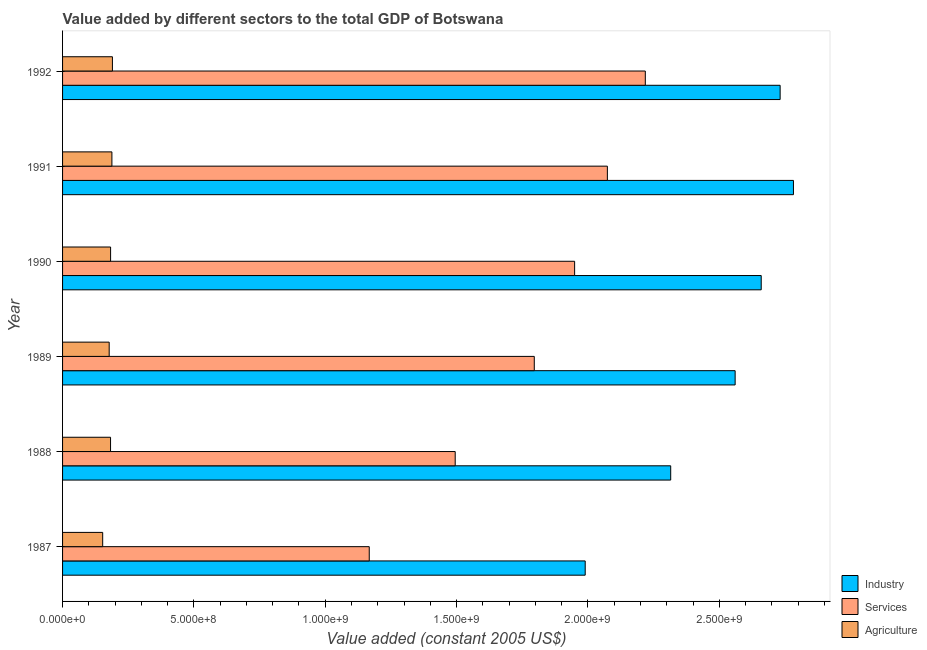How many different coloured bars are there?
Offer a terse response. 3. How many groups of bars are there?
Your answer should be very brief. 6. Are the number of bars on each tick of the Y-axis equal?
Keep it short and to the point. Yes. How many bars are there on the 6th tick from the top?
Make the answer very short. 3. How many bars are there on the 3rd tick from the bottom?
Ensure brevity in your answer.  3. What is the label of the 6th group of bars from the top?
Ensure brevity in your answer.  1987. What is the value added by agricultural sector in 1991?
Offer a terse response. 1.88e+08. Across all years, what is the maximum value added by services?
Your answer should be compact. 2.22e+09. Across all years, what is the minimum value added by industrial sector?
Offer a very short reply. 1.99e+09. In which year was the value added by agricultural sector minimum?
Your answer should be compact. 1987. What is the total value added by agricultural sector in the graph?
Your answer should be compact. 1.07e+09. What is the difference between the value added by industrial sector in 1988 and that in 1990?
Provide a succinct answer. -3.45e+08. What is the difference between the value added by industrial sector in 1992 and the value added by services in 1989?
Provide a short and direct response. 9.36e+08. What is the average value added by services per year?
Provide a short and direct response. 1.78e+09. In the year 1988, what is the difference between the value added by services and value added by agricultural sector?
Provide a succinct answer. 1.31e+09. In how many years, is the value added by agricultural sector greater than 1600000000 US$?
Your response must be concise. 0. What is the ratio of the value added by industrial sector in 1989 to that in 1992?
Keep it short and to the point. 0.94. Is the value added by services in 1988 less than that in 1990?
Make the answer very short. Yes. What is the difference between the highest and the second highest value added by industrial sector?
Provide a short and direct response. 5.07e+07. What is the difference between the highest and the lowest value added by services?
Give a very brief answer. 1.05e+09. In how many years, is the value added by industrial sector greater than the average value added by industrial sector taken over all years?
Give a very brief answer. 4. What does the 3rd bar from the top in 1987 represents?
Your answer should be very brief. Industry. What does the 1st bar from the bottom in 1987 represents?
Make the answer very short. Industry. How many bars are there?
Make the answer very short. 18. Are all the bars in the graph horizontal?
Your answer should be very brief. Yes. How many years are there in the graph?
Ensure brevity in your answer.  6. Are the values on the major ticks of X-axis written in scientific E-notation?
Your answer should be compact. Yes. Does the graph contain any zero values?
Ensure brevity in your answer.  No. Where does the legend appear in the graph?
Make the answer very short. Bottom right. How are the legend labels stacked?
Make the answer very short. Vertical. What is the title of the graph?
Your response must be concise. Value added by different sectors to the total GDP of Botswana. Does "Resident buildings and public services" appear as one of the legend labels in the graph?
Your answer should be compact. No. What is the label or title of the X-axis?
Offer a terse response. Value added (constant 2005 US$). What is the label or title of the Y-axis?
Provide a short and direct response. Year. What is the Value added (constant 2005 US$) in Industry in 1987?
Give a very brief answer. 1.99e+09. What is the Value added (constant 2005 US$) in Services in 1987?
Give a very brief answer. 1.17e+09. What is the Value added (constant 2005 US$) in Agriculture in 1987?
Your answer should be compact. 1.53e+08. What is the Value added (constant 2005 US$) in Industry in 1988?
Provide a short and direct response. 2.32e+09. What is the Value added (constant 2005 US$) in Services in 1988?
Your response must be concise. 1.49e+09. What is the Value added (constant 2005 US$) in Agriculture in 1988?
Offer a terse response. 1.83e+08. What is the Value added (constant 2005 US$) in Industry in 1989?
Offer a very short reply. 2.56e+09. What is the Value added (constant 2005 US$) in Services in 1989?
Your answer should be very brief. 1.80e+09. What is the Value added (constant 2005 US$) of Agriculture in 1989?
Provide a succinct answer. 1.77e+08. What is the Value added (constant 2005 US$) in Industry in 1990?
Your answer should be compact. 2.66e+09. What is the Value added (constant 2005 US$) in Services in 1990?
Make the answer very short. 1.95e+09. What is the Value added (constant 2005 US$) of Agriculture in 1990?
Offer a very short reply. 1.83e+08. What is the Value added (constant 2005 US$) of Industry in 1991?
Your answer should be compact. 2.78e+09. What is the Value added (constant 2005 US$) in Services in 1991?
Offer a terse response. 2.07e+09. What is the Value added (constant 2005 US$) in Agriculture in 1991?
Make the answer very short. 1.88e+08. What is the Value added (constant 2005 US$) in Industry in 1992?
Keep it short and to the point. 2.73e+09. What is the Value added (constant 2005 US$) of Services in 1992?
Offer a very short reply. 2.22e+09. What is the Value added (constant 2005 US$) of Agriculture in 1992?
Give a very brief answer. 1.90e+08. Across all years, what is the maximum Value added (constant 2005 US$) in Industry?
Your answer should be compact. 2.78e+09. Across all years, what is the maximum Value added (constant 2005 US$) of Services?
Give a very brief answer. 2.22e+09. Across all years, what is the maximum Value added (constant 2005 US$) of Agriculture?
Make the answer very short. 1.90e+08. Across all years, what is the minimum Value added (constant 2005 US$) in Industry?
Offer a terse response. 1.99e+09. Across all years, what is the minimum Value added (constant 2005 US$) in Services?
Make the answer very short. 1.17e+09. Across all years, what is the minimum Value added (constant 2005 US$) in Agriculture?
Make the answer very short. 1.53e+08. What is the total Value added (constant 2005 US$) of Industry in the graph?
Give a very brief answer. 1.50e+1. What is the total Value added (constant 2005 US$) of Services in the graph?
Your response must be concise. 1.07e+1. What is the total Value added (constant 2005 US$) of Agriculture in the graph?
Your answer should be very brief. 1.07e+09. What is the difference between the Value added (constant 2005 US$) in Industry in 1987 and that in 1988?
Give a very brief answer. -3.25e+08. What is the difference between the Value added (constant 2005 US$) in Services in 1987 and that in 1988?
Give a very brief answer. -3.27e+08. What is the difference between the Value added (constant 2005 US$) in Agriculture in 1987 and that in 1988?
Ensure brevity in your answer.  -2.99e+07. What is the difference between the Value added (constant 2005 US$) of Industry in 1987 and that in 1989?
Provide a succinct answer. -5.71e+08. What is the difference between the Value added (constant 2005 US$) in Services in 1987 and that in 1989?
Offer a terse response. -6.28e+08. What is the difference between the Value added (constant 2005 US$) in Agriculture in 1987 and that in 1989?
Your answer should be very brief. -2.48e+07. What is the difference between the Value added (constant 2005 US$) of Industry in 1987 and that in 1990?
Provide a succinct answer. -6.70e+08. What is the difference between the Value added (constant 2005 US$) in Services in 1987 and that in 1990?
Ensure brevity in your answer.  -7.82e+08. What is the difference between the Value added (constant 2005 US$) of Agriculture in 1987 and that in 1990?
Provide a succinct answer. -3.01e+07. What is the difference between the Value added (constant 2005 US$) of Industry in 1987 and that in 1991?
Provide a succinct answer. -7.93e+08. What is the difference between the Value added (constant 2005 US$) in Services in 1987 and that in 1991?
Provide a short and direct response. -9.07e+08. What is the difference between the Value added (constant 2005 US$) in Agriculture in 1987 and that in 1991?
Your response must be concise. -3.51e+07. What is the difference between the Value added (constant 2005 US$) of Industry in 1987 and that in 1992?
Offer a very short reply. -7.42e+08. What is the difference between the Value added (constant 2005 US$) of Services in 1987 and that in 1992?
Your response must be concise. -1.05e+09. What is the difference between the Value added (constant 2005 US$) of Agriculture in 1987 and that in 1992?
Ensure brevity in your answer.  -3.71e+07. What is the difference between the Value added (constant 2005 US$) in Industry in 1988 and that in 1989?
Provide a short and direct response. -2.45e+08. What is the difference between the Value added (constant 2005 US$) in Services in 1988 and that in 1989?
Your answer should be compact. -3.01e+08. What is the difference between the Value added (constant 2005 US$) in Agriculture in 1988 and that in 1989?
Give a very brief answer. 5.15e+06. What is the difference between the Value added (constant 2005 US$) of Industry in 1988 and that in 1990?
Provide a short and direct response. -3.45e+08. What is the difference between the Value added (constant 2005 US$) in Services in 1988 and that in 1990?
Your answer should be compact. -4.55e+08. What is the difference between the Value added (constant 2005 US$) in Agriculture in 1988 and that in 1990?
Your answer should be very brief. -1.94e+05. What is the difference between the Value added (constant 2005 US$) in Industry in 1988 and that in 1991?
Make the answer very short. -4.67e+08. What is the difference between the Value added (constant 2005 US$) of Services in 1988 and that in 1991?
Provide a short and direct response. -5.79e+08. What is the difference between the Value added (constant 2005 US$) in Agriculture in 1988 and that in 1991?
Offer a terse response. -5.19e+06. What is the difference between the Value added (constant 2005 US$) of Industry in 1988 and that in 1992?
Your answer should be very brief. -4.17e+08. What is the difference between the Value added (constant 2005 US$) of Services in 1988 and that in 1992?
Offer a terse response. -7.24e+08. What is the difference between the Value added (constant 2005 US$) of Agriculture in 1988 and that in 1992?
Keep it short and to the point. -7.17e+06. What is the difference between the Value added (constant 2005 US$) of Industry in 1989 and that in 1990?
Ensure brevity in your answer.  -9.93e+07. What is the difference between the Value added (constant 2005 US$) of Services in 1989 and that in 1990?
Offer a very short reply. -1.54e+08. What is the difference between the Value added (constant 2005 US$) in Agriculture in 1989 and that in 1990?
Keep it short and to the point. -5.35e+06. What is the difference between the Value added (constant 2005 US$) in Industry in 1989 and that in 1991?
Keep it short and to the point. -2.22e+08. What is the difference between the Value added (constant 2005 US$) of Services in 1989 and that in 1991?
Keep it short and to the point. -2.78e+08. What is the difference between the Value added (constant 2005 US$) in Agriculture in 1989 and that in 1991?
Make the answer very short. -1.03e+07. What is the difference between the Value added (constant 2005 US$) in Industry in 1989 and that in 1992?
Ensure brevity in your answer.  -1.71e+08. What is the difference between the Value added (constant 2005 US$) in Services in 1989 and that in 1992?
Offer a terse response. -4.23e+08. What is the difference between the Value added (constant 2005 US$) of Agriculture in 1989 and that in 1992?
Provide a short and direct response. -1.23e+07. What is the difference between the Value added (constant 2005 US$) in Industry in 1990 and that in 1991?
Keep it short and to the point. -1.23e+08. What is the difference between the Value added (constant 2005 US$) in Services in 1990 and that in 1991?
Provide a short and direct response. -1.25e+08. What is the difference between the Value added (constant 2005 US$) in Agriculture in 1990 and that in 1991?
Ensure brevity in your answer.  -5.00e+06. What is the difference between the Value added (constant 2005 US$) of Industry in 1990 and that in 1992?
Offer a very short reply. -7.20e+07. What is the difference between the Value added (constant 2005 US$) of Services in 1990 and that in 1992?
Give a very brief answer. -2.69e+08. What is the difference between the Value added (constant 2005 US$) of Agriculture in 1990 and that in 1992?
Your answer should be compact. -6.97e+06. What is the difference between the Value added (constant 2005 US$) in Industry in 1991 and that in 1992?
Give a very brief answer. 5.07e+07. What is the difference between the Value added (constant 2005 US$) in Services in 1991 and that in 1992?
Provide a succinct answer. -1.44e+08. What is the difference between the Value added (constant 2005 US$) of Agriculture in 1991 and that in 1992?
Give a very brief answer. -1.98e+06. What is the difference between the Value added (constant 2005 US$) of Industry in 1987 and the Value added (constant 2005 US$) of Services in 1988?
Your answer should be compact. 4.95e+08. What is the difference between the Value added (constant 2005 US$) of Industry in 1987 and the Value added (constant 2005 US$) of Agriculture in 1988?
Offer a very short reply. 1.81e+09. What is the difference between the Value added (constant 2005 US$) in Services in 1987 and the Value added (constant 2005 US$) in Agriculture in 1988?
Your answer should be very brief. 9.85e+08. What is the difference between the Value added (constant 2005 US$) of Industry in 1987 and the Value added (constant 2005 US$) of Services in 1989?
Give a very brief answer. 1.94e+08. What is the difference between the Value added (constant 2005 US$) in Industry in 1987 and the Value added (constant 2005 US$) in Agriculture in 1989?
Provide a succinct answer. 1.81e+09. What is the difference between the Value added (constant 2005 US$) of Services in 1987 and the Value added (constant 2005 US$) of Agriculture in 1989?
Provide a succinct answer. 9.90e+08. What is the difference between the Value added (constant 2005 US$) of Industry in 1987 and the Value added (constant 2005 US$) of Services in 1990?
Your answer should be compact. 4.03e+07. What is the difference between the Value added (constant 2005 US$) of Industry in 1987 and the Value added (constant 2005 US$) of Agriculture in 1990?
Your response must be concise. 1.81e+09. What is the difference between the Value added (constant 2005 US$) in Services in 1987 and the Value added (constant 2005 US$) in Agriculture in 1990?
Your response must be concise. 9.85e+08. What is the difference between the Value added (constant 2005 US$) of Industry in 1987 and the Value added (constant 2005 US$) of Services in 1991?
Make the answer very short. -8.44e+07. What is the difference between the Value added (constant 2005 US$) of Industry in 1987 and the Value added (constant 2005 US$) of Agriculture in 1991?
Offer a terse response. 1.80e+09. What is the difference between the Value added (constant 2005 US$) of Services in 1987 and the Value added (constant 2005 US$) of Agriculture in 1991?
Ensure brevity in your answer.  9.80e+08. What is the difference between the Value added (constant 2005 US$) of Industry in 1987 and the Value added (constant 2005 US$) of Services in 1992?
Your response must be concise. -2.29e+08. What is the difference between the Value added (constant 2005 US$) of Industry in 1987 and the Value added (constant 2005 US$) of Agriculture in 1992?
Offer a terse response. 1.80e+09. What is the difference between the Value added (constant 2005 US$) in Services in 1987 and the Value added (constant 2005 US$) in Agriculture in 1992?
Offer a very short reply. 9.78e+08. What is the difference between the Value added (constant 2005 US$) of Industry in 1988 and the Value added (constant 2005 US$) of Services in 1989?
Make the answer very short. 5.19e+08. What is the difference between the Value added (constant 2005 US$) in Industry in 1988 and the Value added (constant 2005 US$) in Agriculture in 1989?
Ensure brevity in your answer.  2.14e+09. What is the difference between the Value added (constant 2005 US$) in Services in 1988 and the Value added (constant 2005 US$) in Agriculture in 1989?
Keep it short and to the point. 1.32e+09. What is the difference between the Value added (constant 2005 US$) in Industry in 1988 and the Value added (constant 2005 US$) in Services in 1990?
Provide a succinct answer. 3.66e+08. What is the difference between the Value added (constant 2005 US$) of Industry in 1988 and the Value added (constant 2005 US$) of Agriculture in 1990?
Make the answer very short. 2.13e+09. What is the difference between the Value added (constant 2005 US$) in Services in 1988 and the Value added (constant 2005 US$) in Agriculture in 1990?
Keep it short and to the point. 1.31e+09. What is the difference between the Value added (constant 2005 US$) in Industry in 1988 and the Value added (constant 2005 US$) in Services in 1991?
Ensure brevity in your answer.  2.41e+08. What is the difference between the Value added (constant 2005 US$) of Industry in 1988 and the Value added (constant 2005 US$) of Agriculture in 1991?
Your answer should be compact. 2.13e+09. What is the difference between the Value added (constant 2005 US$) of Services in 1988 and the Value added (constant 2005 US$) of Agriculture in 1991?
Offer a terse response. 1.31e+09. What is the difference between the Value added (constant 2005 US$) in Industry in 1988 and the Value added (constant 2005 US$) in Services in 1992?
Ensure brevity in your answer.  9.66e+07. What is the difference between the Value added (constant 2005 US$) of Industry in 1988 and the Value added (constant 2005 US$) of Agriculture in 1992?
Provide a succinct answer. 2.13e+09. What is the difference between the Value added (constant 2005 US$) in Services in 1988 and the Value added (constant 2005 US$) in Agriculture in 1992?
Your response must be concise. 1.30e+09. What is the difference between the Value added (constant 2005 US$) in Industry in 1989 and the Value added (constant 2005 US$) in Services in 1990?
Make the answer very short. 6.11e+08. What is the difference between the Value added (constant 2005 US$) in Industry in 1989 and the Value added (constant 2005 US$) in Agriculture in 1990?
Offer a very short reply. 2.38e+09. What is the difference between the Value added (constant 2005 US$) in Services in 1989 and the Value added (constant 2005 US$) in Agriculture in 1990?
Keep it short and to the point. 1.61e+09. What is the difference between the Value added (constant 2005 US$) of Industry in 1989 and the Value added (constant 2005 US$) of Services in 1991?
Your answer should be compact. 4.86e+08. What is the difference between the Value added (constant 2005 US$) in Industry in 1989 and the Value added (constant 2005 US$) in Agriculture in 1991?
Provide a short and direct response. 2.37e+09. What is the difference between the Value added (constant 2005 US$) in Services in 1989 and the Value added (constant 2005 US$) in Agriculture in 1991?
Provide a short and direct response. 1.61e+09. What is the difference between the Value added (constant 2005 US$) of Industry in 1989 and the Value added (constant 2005 US$) of Services in 1992?
Offer a terse response. 3.42e+08. What is the difference between the Value added (constant 2005 US$) of Industry in 1989 and the Value added (constant 2005 US$) of Agriculture in 1992?
Provide a succinct answer. 2.37e+09. What is the difference between the Value added (constant 2005 US$) in Services in 1989 and the Value added (constant 2005 US$) in Agriculture in 1992?
Your answer should be very brief. 1.61e+09. What is the difference between the Value added (constant 2005 US$) in Industry in 1990 and the Value added (constant 2005 US$) in Services in 1991?
Make the answer very short. 5.86e+08. What is the difference between the Value added (constant 2005 US$) in Industry in 1990 and the Value added (constant 2005 US$) in Agriculture in 1991?
Keep it short and to the point. 2.47e+09. What is the difference between the Value added (constant 2005 US$) in Services in 1990 and the Value added (constant 2005 US$) in Agriculture in 1991?
Your answer should be very brief. 1.76e+09. What is the difference between the Value added (constant 2005 US$) in Industry in 1990 and the Value added (constant 2005 US$) in Services in 1992?
Your answer should be very brief. 4.41e+08. What is the difference between the Value added (constant 2005 US$) of Industry in 1990 and the Value added (constant 2005 US$) of Agriculture in 1992?
Offer a terse response. 2.47e+09. What is the difference between the Value added (constant 2005 US$) in Services in 1990 and the Value added (constant 2005 US$) in Agriculture in 1992?
Your answer should be compact. 1.76e+09. What is the difference between the Value added (constant 2005 US$) of Industry in 1991 and the Value added (constant 2005 US$) of Services in 1992?
Provide a short and direct response. 5.64e+08. What is the difference between the Value added (constant 2005 US$) in Industry in 1991 and the Value added (constant 2005 US$) in Agriculture in 1992?
Keep it short and to the point. 2.59e+09. What is the difference between the Value added (constant 2005 US$) in Services in 1991 and the Value added (constant 2005 US$) in Agriculture in 1992?
Your answer should be very brief. 1.88e+09. What is the average Value added (constant 2005 US$) in Industry per year?
Your answer should be compact. 2.51e+09. What is the average Value added (constant 2005 US$) in Services per year?
Offer a terse response. 1.78e+09. What is the average Value added (constant 2005 US$) in Agriculture per year?
Make the answer very short. 1.79e+08. In the year 1987, what is the difference between the Value added (constant 2005 US$) in Industry and Value added (constant 2005 US$) in Services?
Offer a very short reply. 8.22e+08. In the year 1987, what is the difference between the Value added (constant 2005 US$) of Industry and Value added (constant 2005 US$) of Agriculture?
Provide a short and direct response. 1.84e+09. In the year 1987, what is the difference between the Value added (constant 2005 US$) in Services and Value added (constant 2005 US$) in Agriculture?
Give a very brief answer. 1.01e+09. In the year 1988, what is the difference between the Value added (constant 2005 US$) in Industry and Value added (constant 2005 US$) in Services?
Your answer should be compact. 8.20e+08. In the year 1988, what is the difference between the Value added (constant 2005 US$) of Industry and Value added (constant 2005 US$) of Agriculture?
Keep it short and to the point. 2.13e+09. In the year 1988, what is the difference between the Value added (constant 2005 US$) in Services and Value added (constant 2005 US$) in Agriculture?
Give a very brief answer. 1.31e+09. In the year 1989, what is the difference between the Value added (constant 2005 US$) in Industry and Value added (constant 2005 US$) in Services?
Your answer should be very brief. 7.65e+08. In the year 1989, what is the difference between the Value added (constant 2005 US$) in Industry and Value added (constant 2005 US$) in Agriculture?
Your answer should be very brief. 2.38e+09. In the year 1989, what is the difference between the Value added (constant 2005 US$) in Services and Value added (constant 2005 US$) in Agriculture?
Make the answer very short. 1.62e+09. In the year 1990, what is the difference between the Value added (constant 2005 US$) in Industry and Value added (constant 2005 US$) in Services?
Offer a very short reply. 7.10e+08. In the year 1990, what is the difference between the Value added (constant 2005 US$) in Industry and Value added (constant 2005 US$) in Agriculture?
Offer a very short reply. 2.48e+09. In the year 1990, what is the difference between the Value added (constant 2005 US$) of Services and Value added (constant 2005 US$) of Agriculture?
Provide a succinct answer. 1.77e+09. In the year 1991, what is the difference between the Value added (constant 2005 US$) of Industry and Value added (constant 2005 US$) of Services?
Offer a very short reply. 7.08e+08. In the year 1991, what is the difference between the Value added (constant 2005 US$) of Industry and Value added (constant 2005 US$) of Agriculture?
Keep it short and to the point. 2.59e+09. In the year 1991, what is the difference between the Value added (constant 2005 US$) of Services and Value added (constant 2005 US$) of Agriculture?
Make the answer very short. 1.89e+09. In the year 1992, what is the difference between the Value added (constant 2005 US$) of Industry and Value added (constant 2005 US$) of Services?
Provide a short and direct response. 5.13e+08. In the year 1992, what is the difference between the Value added (constant 2005 US$) in Industry and Value added (constant 2005 US$) in Agriculture?
Your answer should be compact. 2.54e+09. In the year 1992, what is the difference between the Value added (constant 2005 US$) in Services and Value added (constant 2005 US$) in Agriculture?
Offer a terse response. 2.03e+09. What is the ratio of the Value added (constant 2005 US$) in Industry in 1987 to that in 1988?
Provide a succinct answer. 0.86. What is the ratio of the Value added (constant 2005 US$) of Services in 1987 to that in 1988?
Provide a succinct answer. 0.78. What is the ratio of the Value added (constant 2005 US$) of Agriculture in 1987 to that in 1988?
Give a very brief answer. 0.84. What is the ratio of the Value added (constant 2005 US$) of Industry in 1987 to that in 1989?
Make the answer very short. 0.78. What is the ratio of the Value added (constant 2005 US$) in Services in 1987 to that in 1989?
Your answer should be very brief. 0.65. What is the ratio of the Value added (constant 2005 US$) in Agriculture in 1987 to that in 1989?
Provide a succinct answer. 0.86. What is the ratio of the Value added (constant 2005 US$) of Industry in 1987 to that in 1990?
Keep it short and to the point. 0.75. What is the ratio of the Value added (constant 2005 US$) of Services in 1987 to that in 1990?
Offer a very short reply. 0.6. What is the ratio of the Value added (constant 2005 US$) of Agriculture in 1987 to that in 1990?
Ensure brevity in your answer.  0.84. What is the ratio of the Value added (constant 2005 US$) of Industry in 1987 to that in 1991?
Your answer should be compact. 0.72. What is the ratio of the Value added (constant 2005 US$) of Services in 1987 to that in 1991?
Your answer should be very brief. 0.56. What is the ratio of the Value added (constant 2005 US$) in Agriculture in 1987 to that in 1991?
Make the answer very short. 0.81. What is the ratio of the Value added (constant 2005 US$) in Industry in 1987 to that in 1992?
Your response must be concise. 0.73. What is the ratio of the Value added (constant 2005 US$) of Services in 1987 to that in 1992?
Your answer should be compact. 0.53. What is the ratio of the Value added (constant 2005 US$) of Agriculture in 1987 to that in 1992?
Make the answer very short. 0.8. What is the ratio of the Value added (constant 2005 US$) in Industry in 1988 to that in 1989?
Keep it short and to the point. 0.9. What is the ratio of the Value added (constant 2005 US$) of Services in 1988 to that in 1989?
Give a very brief answer. 0.83. What is the ratio of the Value added (constant 2005 US$) of Industry in 1988 to that in 1990?
Offer a terse response. 0.87. What is the ratio of the Value added (constant 2005 US$) of Services in 1988 to that in 1990?
Offer a terse response. 0.77. What is the ratio of the Value added (constant 2005 US$) in Agriculture in 1988 to that in 1990?
Keep it short and to the point. 1. What is the ratio of the Value added (constant 2005 US$) in Industry in 1988 to that in 1991?
Keep it short and to the point. 0.83. What is the ratio of the Value added (constant 2005 US$) of Services in 1988 to that in 1991?
Offer a terse response. 0.72. What is the ratio of the Value added (constant 2005 US$) of Agriculture in 1988 to that in 1991?
Provide a succinct answer. 0.97. What is the ratio of the Value added (constant 2005 US$) in Industry in 1988 to that in 1992?
Ensure brevity in your answer.  0.85. What is the ratio of the Value added (constant 2005 US$) of Services in 1988 to that in 1992?
Provide a succinct answer. 0.67. What is the ratio of the Value added (constant 2005 US$) of Agriculture in 1988 to that in 1992?
Provide a short and direct response. 0.96. What is the ratio of the Value added (constant 2005 US$) in Industry in 1989 to that in 1990?
Give a very brief answer. 0.96. What is the ratio of the Value added (constant 2005 US$) of Services in 1989 to that in 1990?
Ensure brevity in your answer.  0.92. What is the ratio of the Value added (constant 2005 US$) of Agriculture in 1989 to that in 1990?
Provide a succinct answer. 0.97. What is the ratio of the Value added (constant 2005 US$) in Industry in 1989 to that in 1991?
Your answer should be very brief. 0.92. What is the ratio of the Value added (constant 2005 US$) in Services in 1989 to that in 1991?
Ensure brevity in your answer.  0.87. What is the ratio of the Value added (constant 2005 US$) in Agriculture in 1989 to that in 1991?
Your answer should be very brief. 0.94. What is the ratio of the Value added (constant 2005 US$) in Industry in 1989 to that in 1992?
Your answer should be compact. 0.94. What is the ratio of the Value added (constant 2005 US$) of Services in 1989 to that in 1992?
Your answer should be very brief. 0.81. What is the ratio of the Value added (constant 2005 US$) of Agriculture in 1989 to that in 1992?
Give a very brief answer. 0.94. What is the ratio of the Value added (constant 2005 US$) of Industry in 1990 to that in 1991?
Give a very brief answer. 0.96. What is the ratio of the Value added (constant 2005 US$) in Services in 1990 to that in 1991?
Keep it short and to the point. 0.94. What is the ratio of the Value added (constant 2005 US$) of Agriculture in 1990 to that in 1991?
Ensure brevity in your answer.  0.97. What is the ratio of the Value added (constant 2005 US$) in Industry in 1990 to that in 1992?
Provide a short and direct response. 0.97. What is the ratio of the Value added (constant 2005 US$) in Services in 1990 to that in 1992?
Your answer should be compact. 0.88. What is the ratio of the Value added (constant 2005 US$) in Agriculture in 1990 to that in 1992?
Provide a short and direct response. 0.96. What is the ratio of the Value added (constant 2005 US$) in Industry in 1991 to that in 1992?
Your answer should be compact. 1.02. What is the ratio of the Value added (constant 2005 US$) in Services in 1991 to that in 1992?
Give a very brief answer. 0.93. What is the ratio of the Value added (constant 2005 US$) in Agriculture in 1991 to that in 1992?
Offer a terse response. 0.99. What is the difference between the highest and the second highest Value added (constant 2005 US$) in Industry?
Provide a succinct answer. 5.07e+07. What is the difference between the highest and the second highest Value added (constant 2005 US$) of Services?
Your answer should be compact. 1.44e+08. What is the difference between the highest and the second highest Value added (constant 2005 US$) of Agriculture?
Offer a terse response. 1.98e+06. What is the difference between the highest and the lowest Value added (constant 2005 US$) in Industry?
Ensure brevity in your answer.  7.93e+08. What is the difference between the highest and the lowest Value added (constant 2005 US$) of Services?
Make the answer very short. 1.05e+09. What is the difference between the highest and the lowest Value added (constant 2005 US$) of Agriculture?
Keep it short and to the point. 3.71e+07. 